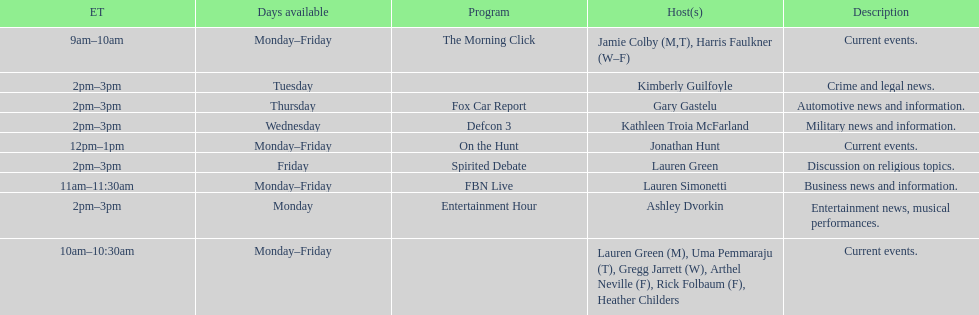Parse the table in full. {'header': ['ET', 'Days available', 'Program', 'Host(s)', 'Description'], 'rows': [['9am–10am', 'Monday–Friday', 'The Morning Click', 'Jamie Colby (M,T), Harris Faulkner (W–F)', 'Current events.'], ['2pm–3pm', 'Tuesday', '', 'Kimberly Guilfoyle', 'Crime and legal news.'], ['2pm–3pm', 'Thursday', 'Fox Car Report', 'Gary Gastelu', 'Automotive news and information.'], ['2pm–3pm', 'Wednesday', 'Defcon 3', 'Kathleen Troia McFarland', 'Military news and information.'], ['12pm–1pm', 'Monday–Friday', 'On the Hunt', 'Jonathan Hunt', 'Current events.'], ['2pm–3pm', 'Friday', 'Spirited Debate', 'Lauren Green', 'Discussion on religious topics.'], ['11am–11:30am', 'Monday–Friday', 'FBN Live', 'Lauren Simonetti', 'Business news and information.'], ['2pm–3pm', 'Monday', 'Entertainment Hour', 'Ashley Dvorkin', 'Entertainment news, musical performances.'], ['10am–10:30am', 'Monday–Friday', '', 'Lauren Green (M), Uma Pemmaraju (T), Gregg Jarrett (W), Arthel Neville (F), Rick Folbaum (F), Heather Childers', 'Current events.']]} How many days during the week does the show fbn live air? 5. 